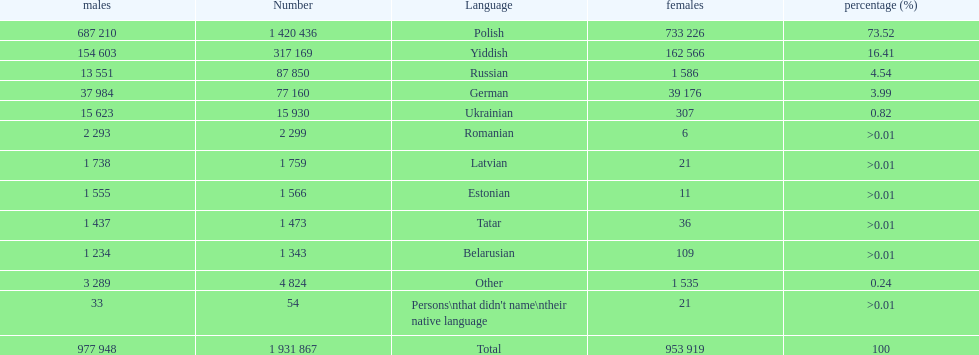Could you help me parse every detail presented in this table? {'header': ['males', 'Number', 'Language', 'females', 'percentage (%)'], 'rows': [['687 210', '1 420 436', 'Polish', '733 226', '73.52'], ['154 603', '317 169', 'Yiddish', '162 566', '16.41'], ['13 551', '87 850', 'Russian', '1 586', '4.54'], ['37 984', '77 160', 'German', '39 176', '3.99'], ['15 623', '15 930', 'Ukrainian', '307', '0.82'], ['2 293', '2 299', 'Romanian', '6', '>0.01'], ['1 738', '1 759', 'Latvian', '21', '>0.01'], ['1 555', '1 566', 'Estonian', '11', '>0.01'], ['1 437', '1 473', 'Tatar', '36', '>0.01'], ['1 234', '1 343', 'Belarusian', '109', '>0.01'], ['3 289', '4 824', 'Other', '1 535', '0.24'], ['33', '54', "Persons\\nthat didn't name\\ntheir native language", '21', '>0.01'], ['977 948', '1 931 867', 'Total', '953 919', '100']]} 01? Romanian. 